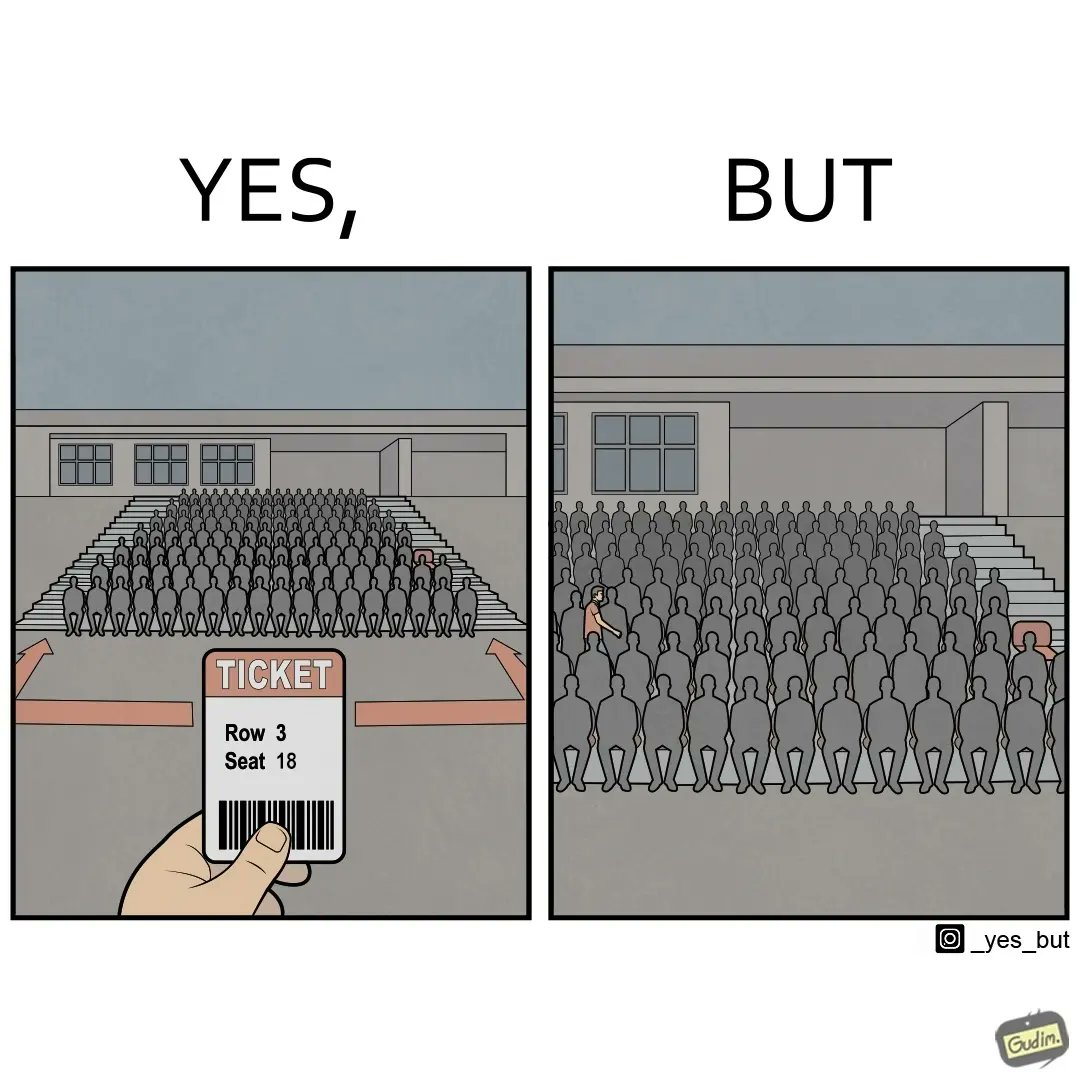Is this a satirical image? Yes, this image is satirical. 